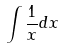<formula> <loc_0><loc_0><loc_500><loc_500>\int \frac { 1 } { x } d x</formula> 